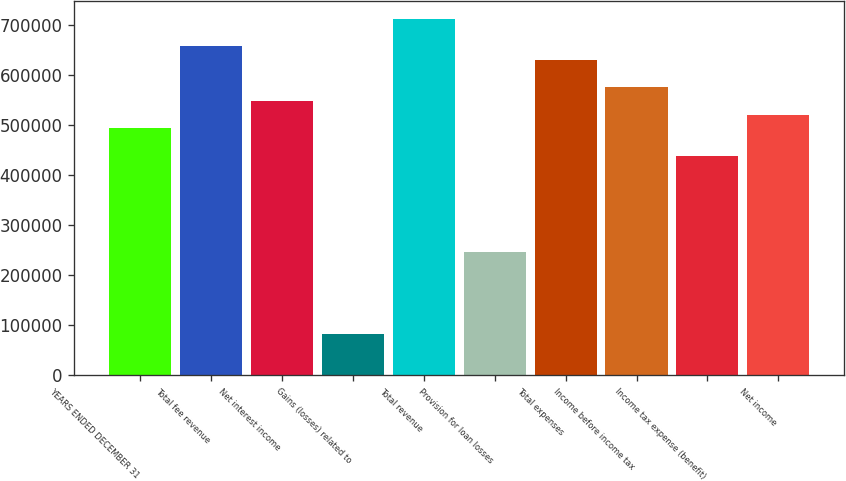<chart> <loc_0><loc_0><loc_500><loc_500><bar_chart><fcel>YEARS ENDED DECEMBER 31<fcel>Total fee revenue<fcel>Net interest income<fcel>Gains (losses) related to<fcel>Total revenue<fcel>Provision for loan losses<fcel>Total expenses<fcel>Income before income tax<fcel>Income tax expense (benefit)<fcel>Net income<nl><fcel>493359<fcel>657812<fcel>548177<fcel>82227.3<fcel>712630<fcel>246680<fcel>630404<fcel>575586<fcel>438542<fcel>520768<nl></chart> 